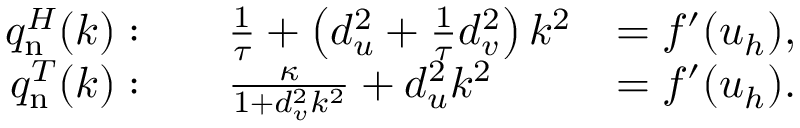<formula> <loc_0><loc_0><loc_500><loc_500>{ \begin{array} { r l r } { q _ { n } ^ { H } ( k ) \colon } & { \quad \frac { 1 } { \tau } + \left ( d _ { u } ^ { 2 } + { \frac { 1 } { \tau } } d _ { v } ^ { 2 } \right ) k ^ { 2 } } & { = f ^ { \prime } ( u _ { h } ) , } \\ { q _ { n } ^ { T } ( k ) \colon } & { \quad \frac { \kappa } { 1 + d _ { v } ^ { 2 } k ^ { 2 } } + d _ { u } ^ { 2 } k ^ { 2 } } & { = f ^ { \prime } ( u _ { h } ) . } \end{array} }</formula> 